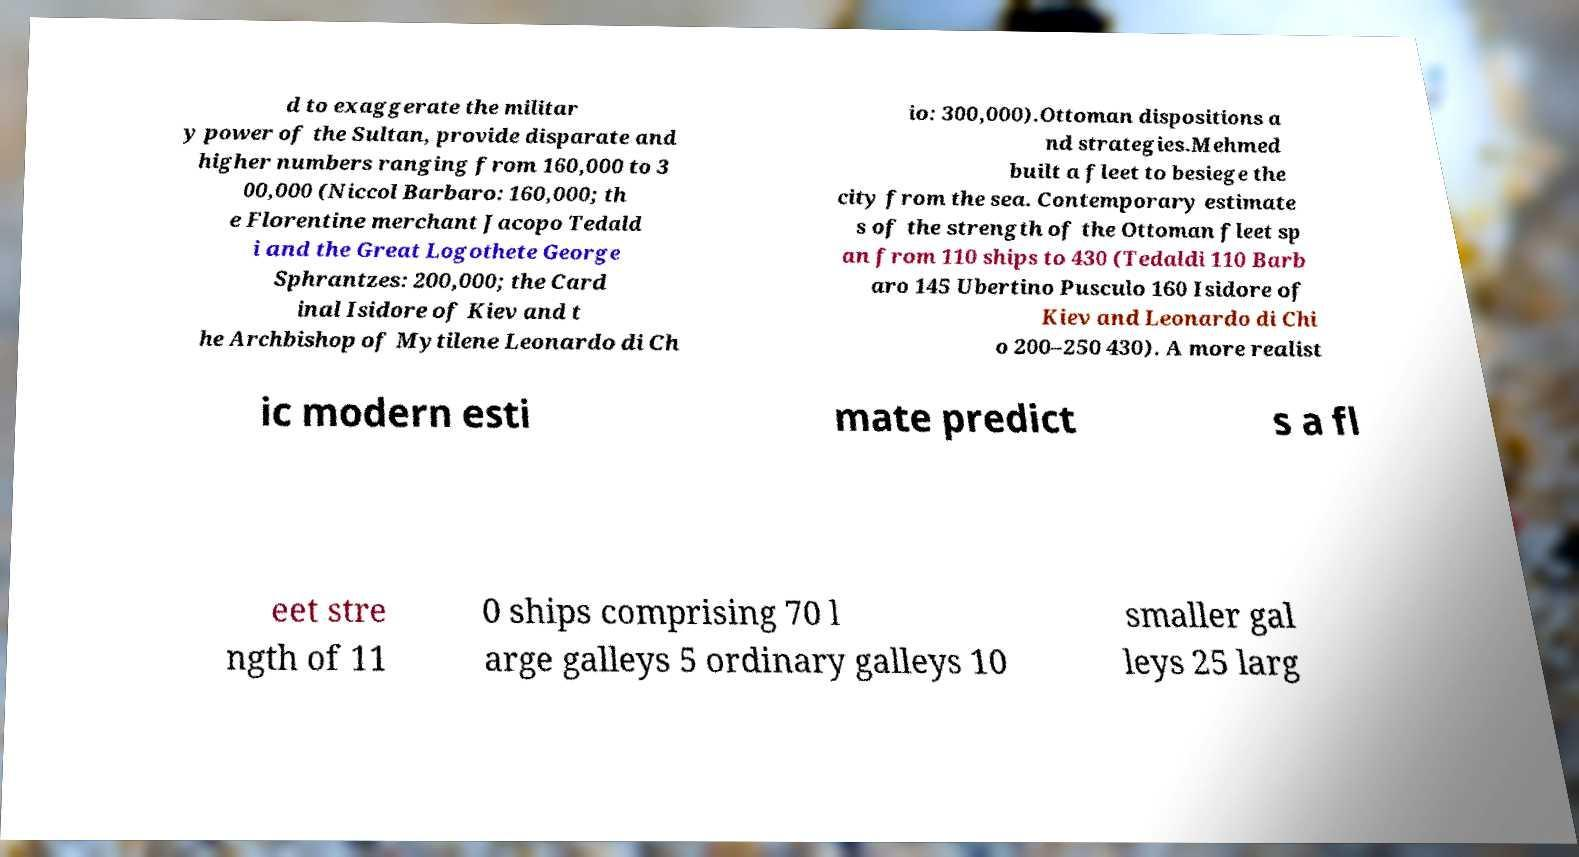For documentation purposes, I need the text within this image transcribed. Could you provide that? d to exaggerate the militar y power of the Sultan, provide disparate and higher numbers ranging from 160,000 to 3 00,000 (Niccol Barbaro: 160,000; th e Florentine merchant Jacopo Tedald i and the Great Logothete George Sphrantzes: 200,000; the Card inal Isidore of Kiev and t he Archbishop of Mytilene Leonardo di Ch io: 300,000).Ottoman dispositions a nd strategies.Mehmed built a fleet to besiege the city from the sea. Contemporary estimate s of the strength of the Ottoman fleet sp an from 110 ships to 430 (Tedaldi 110 Barb aro 145 Ubertino Pusculo 160 Isidore of Kiev and Leonardo di Chi o 200–250 430). A more realist ic modern esti mate predict s a fl eet stre ngth of 11 0 ships comprising 70 l arge galleys 5 ordinary galleys 10 smaller gal leys 25 larg 